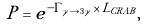Convert formula to latex. <formula><loc_0><loc_0><loc_500><loc_500>P = e ^ { - \Gamma _ { \gamma \to 3 \gamma } \, \times \, L _ { C R A B } } ,</formula> 